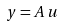<formula> <loc_0><loc_0><loc_500><loc_500>y = A \, u</formula> 